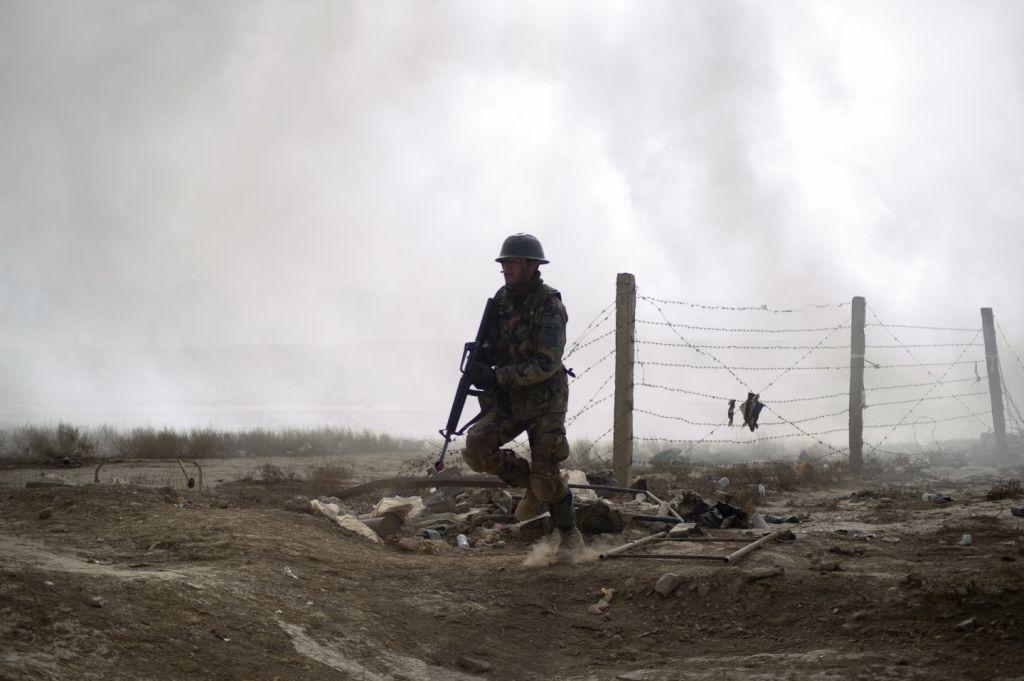Can you describe this image briefly? In this picture I can see there is a man walking wearing a military uniform and he is wearing a helmet and holding a weapon and there is a fence in the backdrop and there are few rocks and there is soil on the ground and there are plants. I can see smoke in the background. 